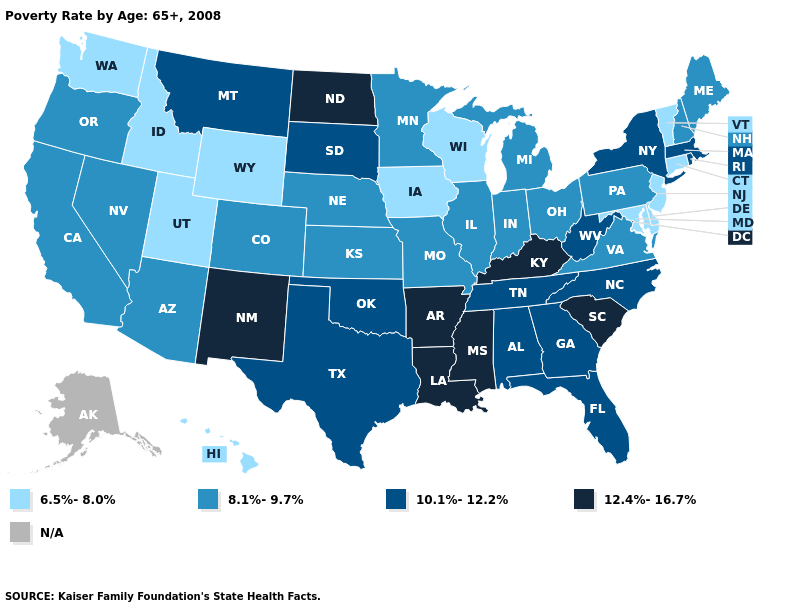What is the highest value in the USA?
Give a very brief answer. 12.4%-16.7%. What is the highest value in the MidWest ?
Be succinct. 12.4%-16.7%. Which states have the highest value in the USA?
Keep it brief. Arkansas, Kentucky, Louisiana, Mississippi, New Mexico, North Dakota, South Carolina. Which states hav the highest value in the Northeast?
Write a very short answer. Massachusetts, New York, Rhode Island. What is the value of Virginia?
Be succinct. 8.1%-9.7%. Name the states that have a value in the range 6.5%-8.0%?
Concise answer only. Connecticut, Delaware, Hawaii, Idaho, Iowa, Maryland, New Jersey, Utah, Vermont, Washington, Wisconsin, Wyoming. What is the value of New York?
Answer briefly. 10.1%-12.2%. Which states hav the highest value in the Northeast?
Concise answer only. Massachusetts, New York, Rhode Island. Among the states that border South Dakota , does Nebraska have the highest value?
Answer briefly. No. Among the states that border Illinois , which have the lowest value?
Be succinct. Iowa, Wisconsin. Does Tennessee have the highest value in the South?
Short answer required. No. What is the value of Pennsylvania?
Concise answer only. 8.1%-9.7%. What is the lowest value in states that border Ohio?
Answer briefly. 8.1%-9.7%. 